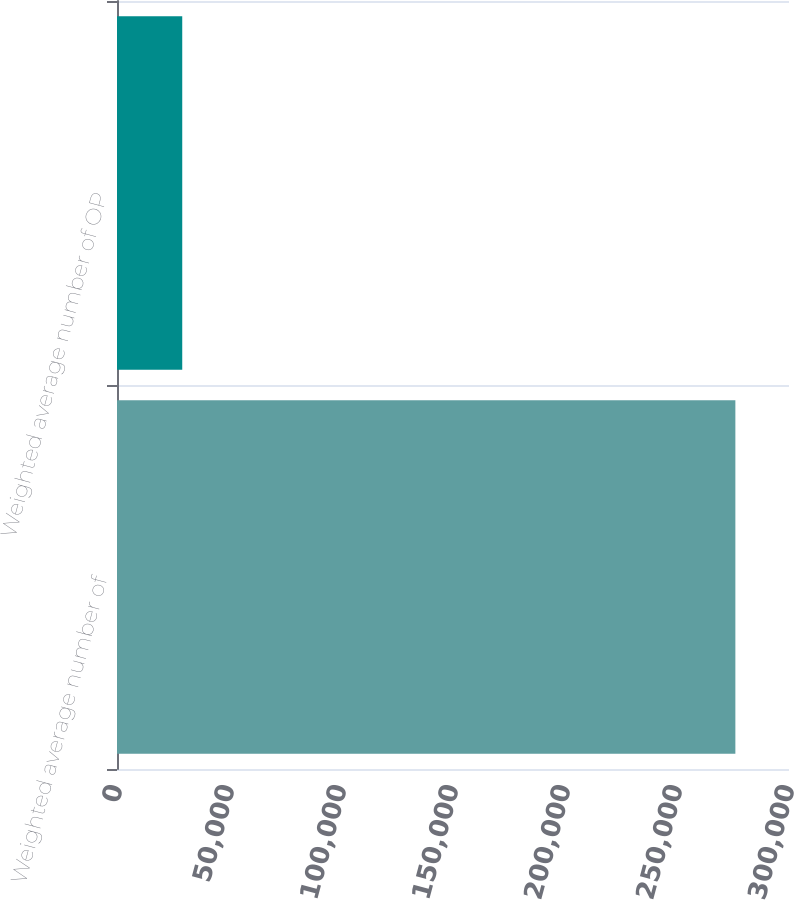Convert chart. <chart><loc_0><loc_0><loc_500><loc_500><bar_chart><fcel>Weighted average number of<fcel>Weighted average number of OP<nl><fcel>276058<fcel>29125<nl></chart> 